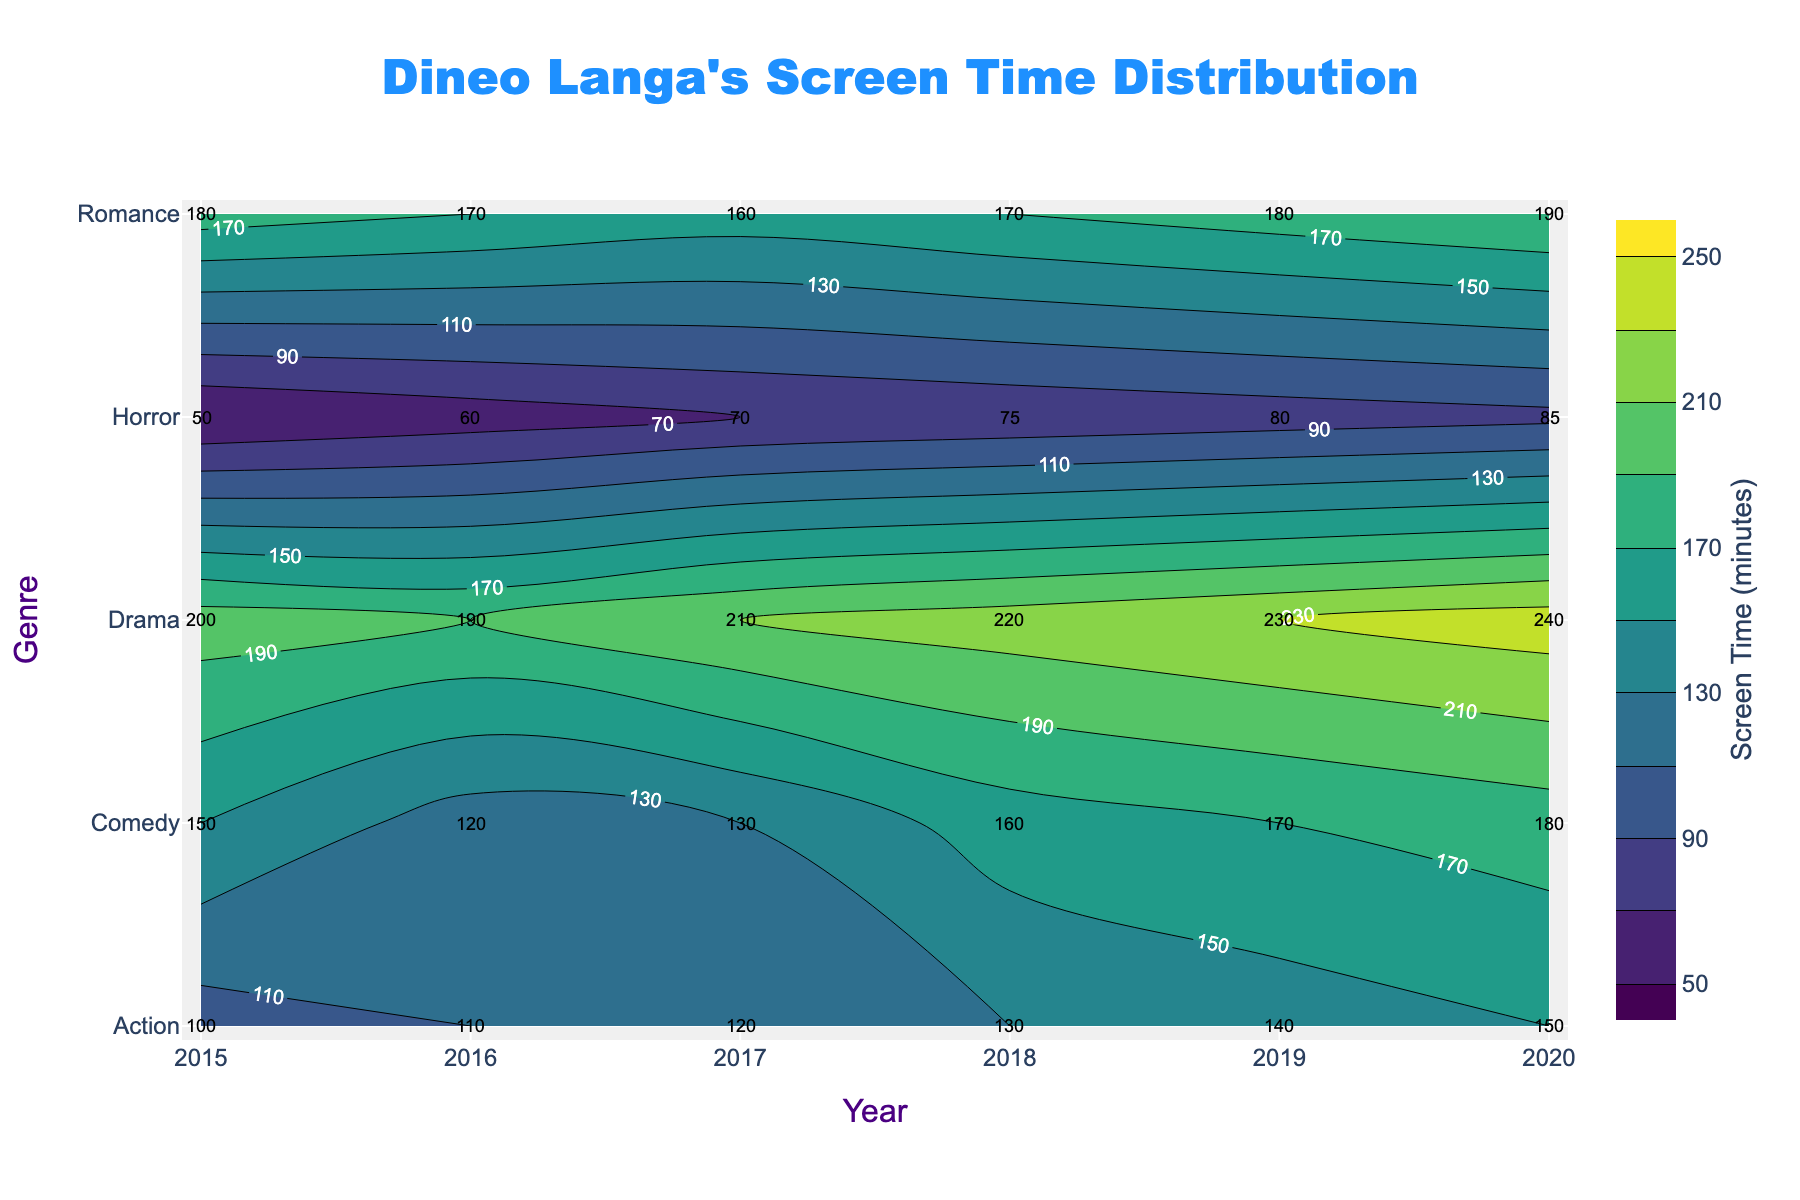What is the title of the figure? The title is usually placed at the top of the figure and is clearly mentioned in a larger and distinctive font.
Answer: Dineo Langa's Screen Time Distribution Which genre had the highest screen time in 2020? By examining the contour plot and looking at the labels for the year 2020, the genre with the highest value will have the highest screen time.
Answer: Drama What does the color scale represent? The color scale on the contour plot indicates the range of screen time in minutes. This is usually shown on the side of the plot.
Answer: Screen Time (minutes) Which year did Dineo Langa's comedy screen time reach 150 minutes? Find the color gradient corresponding to 150 minutes and locate the intersection on the contour plot under the 'Comedy' genre.
Answer: 2015 How does Dineo Langa's screen time in Horror evolve from 2015 to 2020? Examine the contour labels under the 'Horror' genre and trace the changes along the years from 2015 to 2020. The values show an increasing trend from 50 to 85 minutes.
Answer: It increases Which genre had the least variation in screen time over the years? Look at the contour lines: the genre with the least elevation change in the lines will have the least variation. Romance appears the most stable.
Answer: Romance Between Drama and Comedy, which saw a larger increase in screen time from 2015 to 2020? Calculate the difference in screen time for Drama and Comedy from 2015 to 2020 using the contour labels. Drama increased by 40 minutes, while Comedy increased by 30 minutes.
Answer: Drama What was Dineo Langa's average screen time across all genres in 2018? Sum the screen time values across all genres for the year 2018 and divide by the number of genres. The sum is 220 (Drama) + 160 (Comedy) + 130 (Action) + 170 (Romance) + 75 (Horror) = 755. Average is 755 / 5 = 151.
Answer: 151 minutes Which genre had the lowest screen time in 2016? By examining the contour labels for the year 2016 across all genres, the genre with the smallest value is Horror with 60 minutes.
Answer: Horror How many genres did Dineo Langa appear in every year from 2015 to 2020? Count the number of genres that are represented consistently every year on the contour plot. Drama, Comedy, Action, Romance, and Horror are all shown each year.
Answer: 5 genres 